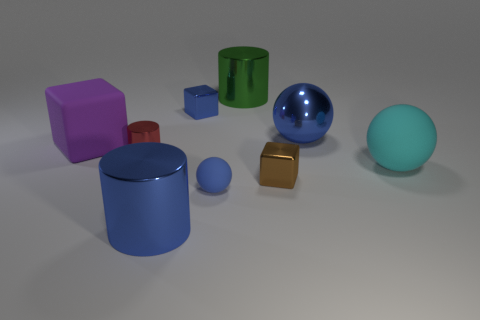How many things are shiny cylinders behind the purple object or things on the right side of the brown cube?
Give a very brief answer. 3. There is a metallic thing that is to the right of the brown shiny block; what number of metallic things are in front of it?
Ensure brevity in your answer.  3. There is a big rubber thing that is right of the green cylinder; is its shape the same as the green object that is behind the large blue metal ball?
Keep it short and to the point. No. What is the shape of the large shiny object that is the same color as the metal sphere?
Make the answer very short. Cylinder. Are there any other big purple objects made of the same material as the purple thing?
Provide a succinct answer. No. What number of metal things are small cubes or blue spheres?
Your answer should be very brief. 3. What shape is the large shiny object that is left of the tiny blue thing behind the large blue ball?
Give a very brief answer. Cylinder. Are there fewer tiny rubber spheres that are right of the large cyan object than large blue shiny cylinders?
Make the answer very short. Yes. The big purple object is what shape?
Offer a very short reply. Cube. What is the size of the shiny cylinder that is behind the purple cube?
Keep it short and to the point. Large. 